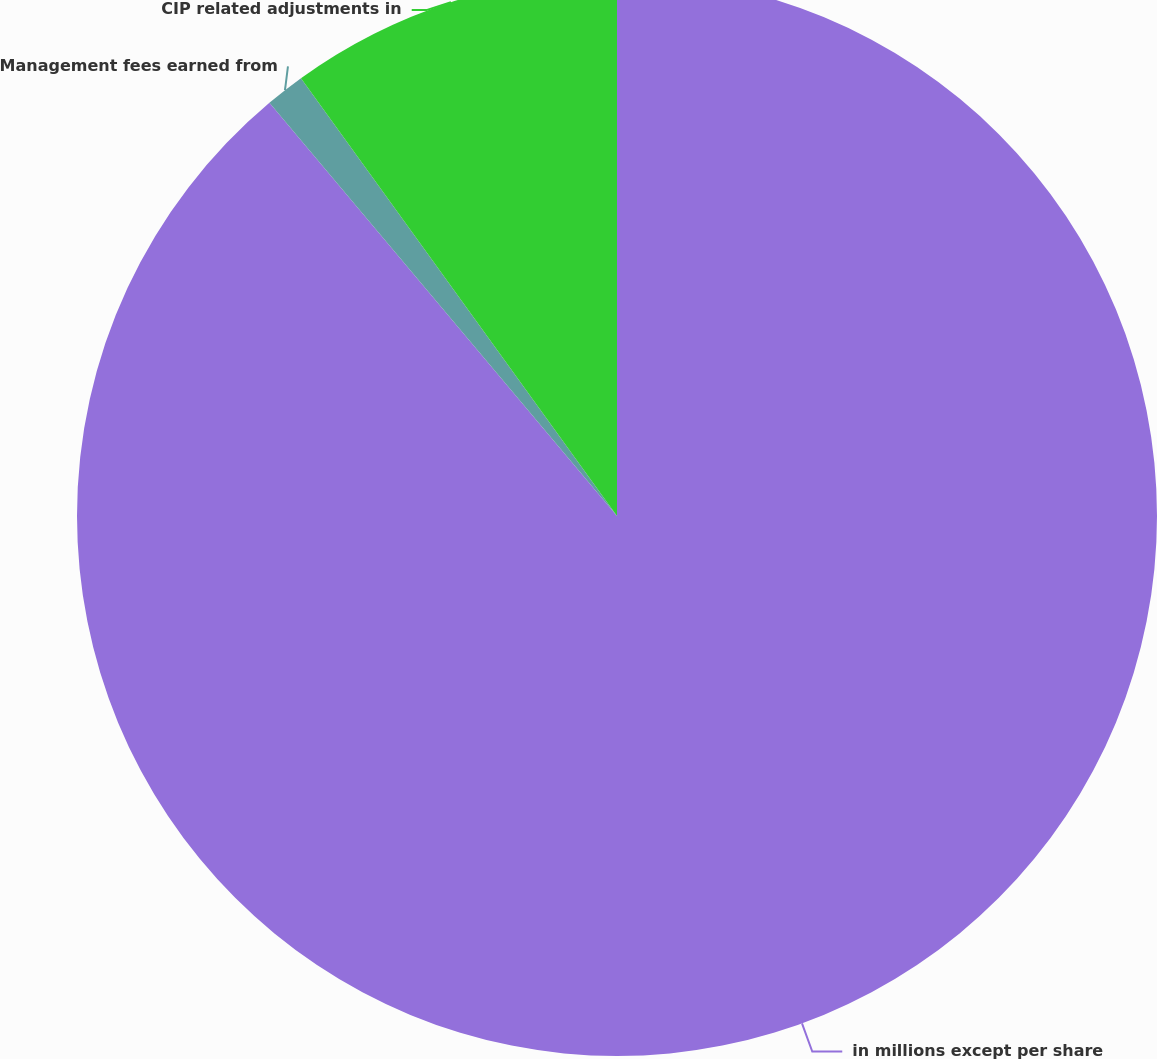<chart> <loc_0><loc_0><loc_500><loc_500><pie_chart><fcel>in millions except per share<fcel>Management fees earned from<fcel>CIP related adjustments in<nl><fcel>88.87%<fcel>1.18%<fcel>9.95%<nl></chart> 